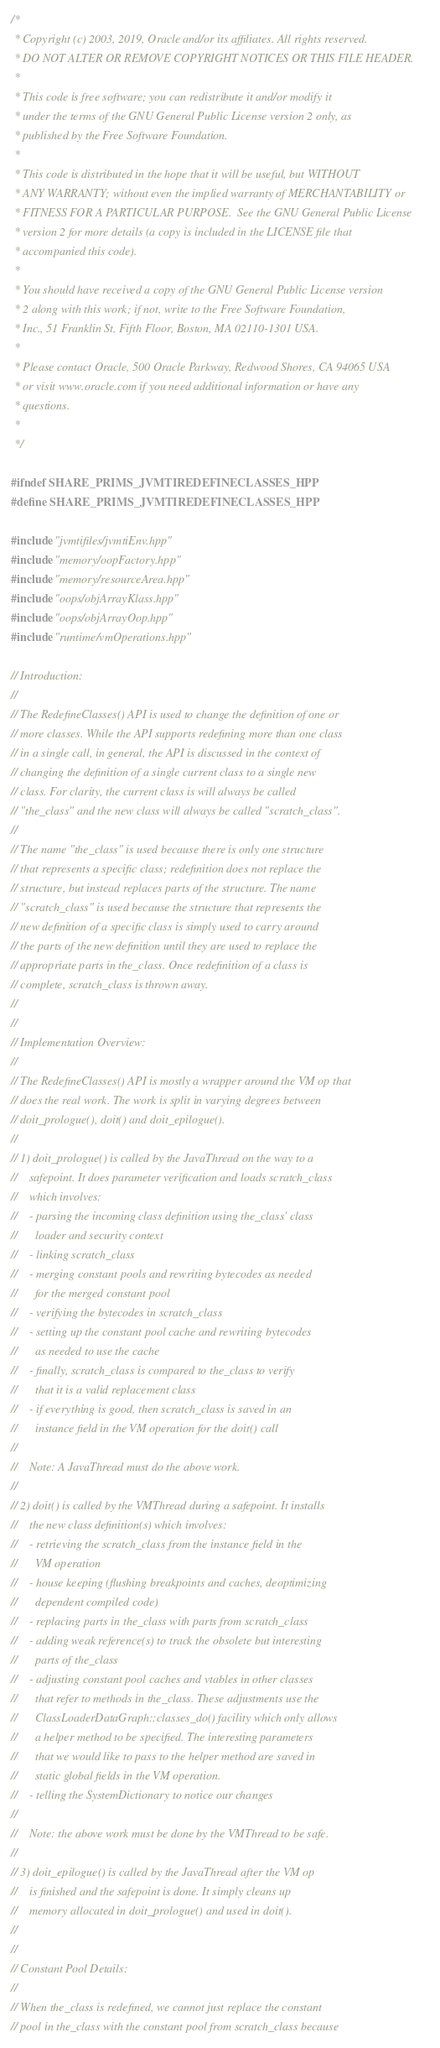<code> <loc_0><loc_0><loc_500><loc_500><_C++_>/*
 * Copyright (c) 2003, 2019, Oracle and/or its affiliates. All rights reserved.
 * DO NOT ALTER OR REMOVE COPYRIGHT NOTICES OR THIS FILE HEADER.
 *
 * This code is free software; you can redistribute it and/or modify it
 * under the terms of the GNU General Public License version 2 only, as
 * published by the Free Software Foundation.
 *
 * This code is distributed in the hope that it will be useful, but WITHOUT
 * ANY WARRANTY; without even the implied warranty of MERCHANTABILITY or
 * FITNESS FOR A PARTICULAR PURPOSE.  See the GNU General Public License
 * version 2 for more details (a copy is included in the LICENSE file that
 * accompanied this code).
 *
 * You should have received a copy of the GNU General Public License version
 * 2 along with this work; if not, write to the Free Software Foundation,
 * Inc., 51 Franklin St, Fifth Floor, Boston, MA 02110-1301 USA.
 *
 * Please contact Oracle, 500 Oracle Parkway, Redwood Shores, CA 94065 USA
 * or visit www.oracle.com if you need additional information or have any
 * questions.
 *
 */

#ifndef SHARE_PRIMS_JVMTIREDEFINECLASSES_HPP
#define SHARE_PRIMS_JVMTIREDEFINECLASSES_HPP

#include "jvmtifiles/jvmtiEnv.hpp"
#include "memory/oopFactory.hpp"
#include "memory/resourceArea.hpp"
#include "oops/objArrayKlass.hpp"
#include "oops/objArrayOop.hpp"
#include "runtime/vmOperations.hpp"

// Introduction:
//
// The RedefineClasses() API is used to change the definition of one or
// more classes. While the API supports redefining more than one class
// in a single call, in general, the API is discussed in the context of
// changing the definition of a single current class to a single new
// class. For clarity, the current class is will always be called
// "the_class" and the new class will always be called "scratch_class".
//
// The name "the_class" is used because there is only one structure
// that represents a specific class; redefinition does not replace the
// structure, but instead replaces parts of the structure. The name
// "scratch_class" is used because the structure that represents the
// new definition of a specific class is simply used to carry around
// the parts of the new definition until they are used to replace the
// appropriate parts in the_class. Once redefinition of a class is
// complete, scratch_class is thrown away.
//
//
// Implementation Overview:
//
// The RedefineClasses() API is mostly a wrapper around the VM op that
// does the real work. The work is split in varying degrees between
// doit_prologue(), doit() and doit_epilogue().
//
// 1) doit_prologue() is called by the JavaThread on the way to a
//    safepoint. It does parameter verification and loads scratch_class
//    which involves:
//    - parsing the incoming class definition using the_class' class
//      loader and security context
//    - linking scratch_class
//    - merging constant pools and rewriting bytecodes as needed
//      for the merged constant pool
//    - verifying the bytecodes in scratch_class
//    - setting up the constant pool cache and rewriting bytecodes
//      as needed to use the cache
//    - finally, scratch_class is compared to the_class to verify
//      that it is a valid replacement class
//    - if everything is good, then scratch_class is saved in an
//      instance field in the VM operation for the doit() call
//
//    Note: A JavaThread must do the above work.
//
// 2) doit() is called by the VMThread during a safepoint. It installs
//    the new class definition(s) which involves:
//    - retrieving the scratch_class from the instance field in the
//      VM operation
//    - house keeping (flushing breakpoints and caches, deoptimizing
//      dependent compiled code)
//    - replacing parts in the_class with parts from scratch_class
//    - adding weak reference(s) to track the obsolete but interesting
//      parts of the_class
//    - adjusting constant pool caches and vtables in other classes
//      that refer to methods in the_class. These adjustments use the
//      ClassLoaderDataGraph::classes_do() facility which only allows
//      a helper method to be specified. The interesting parameters
//      that we would like to pass to the helper method are saved in
//      static global fields in the VM operation.
//    - telling the SystemDictionary to notice our changes
//
//    Note: the above work must be done by the VMThread to be safe.
//
// 3) doit_epilogue() is called by the JavaThread after the VM op
//    is finished and the safepoint is done. It simply cleans up
//    memory allocated in doit_prologue() and used in doit().
//
//
// Constant Pool Details:
//
// When the_class is redefined, we cannot just replace the constant
// pool in the_class with the constant pool from scratch_class because</code> 